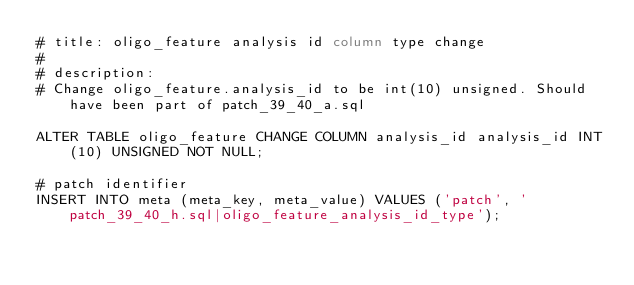Convert code to text. <code><loc_0><loc_0><loc_500><loc_500><_SQL_># title: oligo_feature analysis id column type change
#
# description:
# Change oligo_feature.analysis_id to be int(10) unsigned. Should have been part of patch_39_40_a.sql

ALTER TABLE oligo_feature CHANGE COLUMN analysis_id analysis_id INT(10) UNSIGNED NOT NULL;

# patch identifier
INSERT INTO meta (meta_key, meta_value) VALUES ('patch', 'patch_39_40_h.sql|oligo_feature_analysis_id_type');

</code> 